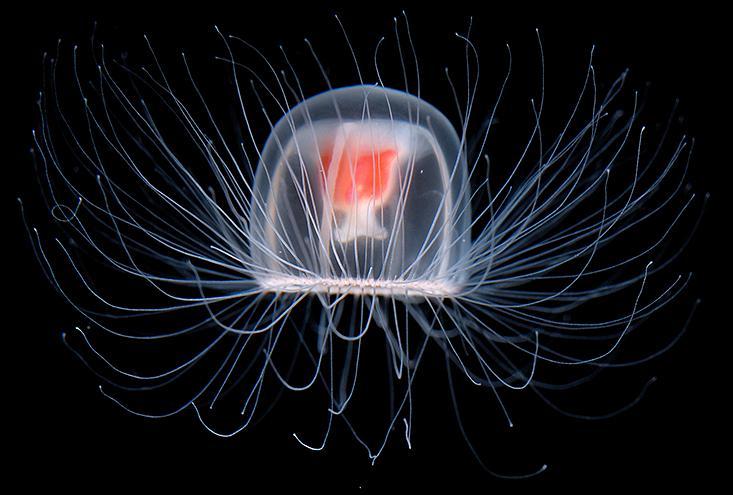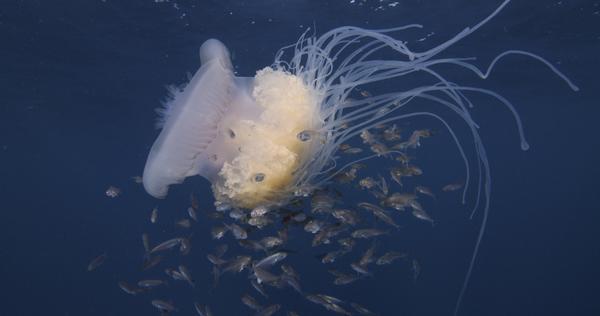The first image is the image on the left, the second image is the image on the right. Given the left and right images, does the statement "Right and left images each show the same neutral-colored type of jellyfish." hold true? Answer yes or no. No. The first image is the image on the left, the second image is the image on the right. For the images displayed, is the sentence "The right image has fewer than four jellyfish." factually correct? Answer yes or no. Yes. 